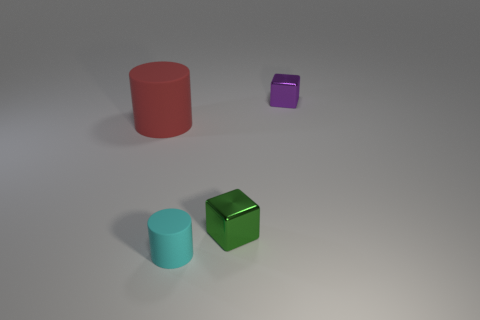Is the number of big red cylinders that are behind the big rubber cylinder the same as the number of small cyan rubber cylinders?
Provide a succinct answer. No. What is the color of the large rubber cylinder?
Give a very brief answer. Red. What size is the other object that is made of the same material as the green thing?
Offer a very short reply. Small. What is the color of the thing that is made of the same material as the small cylinder?
Your response must be concise. Red. Is there a rubber cylinder that has the same size as the purple cube?
Your answer should be very brief. Yes. There is another object that is the same shape as the big rubber object; what is its material?
Your answer should be very brief. Rubber. What is the shape of the purple object that is the same size as the green object?
Your response must be concise. Cube. Are there any small matte objects of the same shape as the large red object?
Provide a short and direct response. Yes. What is the shape of the tiny shiny thing that is on the right side of the tiny metallic thing that is in front of the large red object?
Make the answer very short. Cube. What shape is the big red matte object?
Ensure brevity in your answer.  Cylinder. 